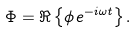Convert formula to latex. <formula><loc_0><loc_0><loc_500><loc_500>\Phi = \Re \left \{ \phi \, e ^ { - i \omega t } \right \} .</formula> 